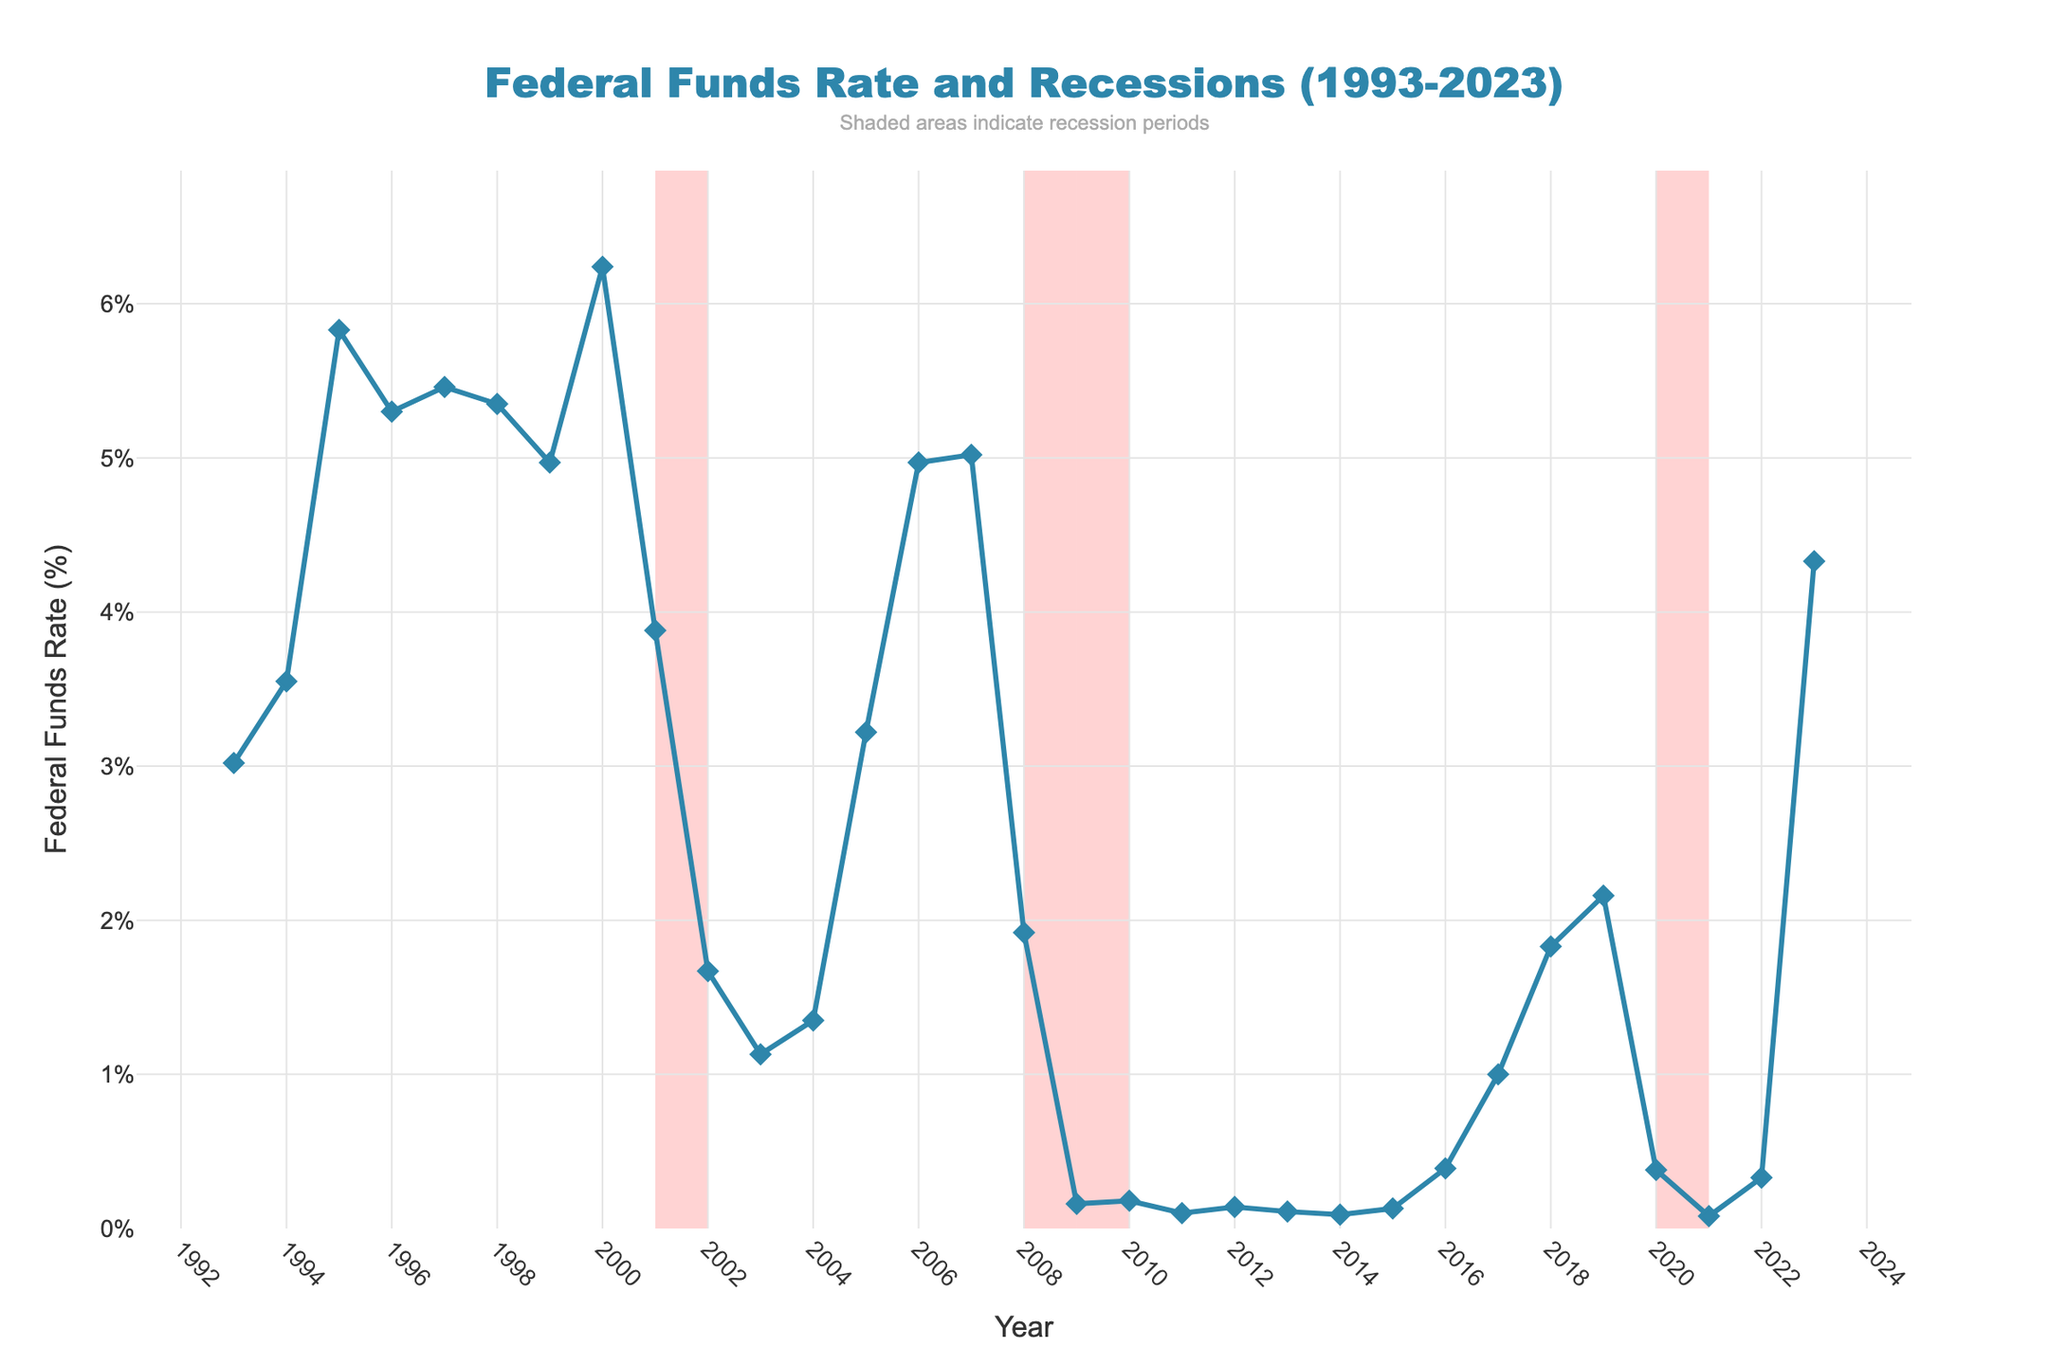What is the highest level reached by the Federal Funds Rate over the past 30 years? The highest rate can be identified by looking for the peak value on the Federal Funds Rate line on the chart. This peak occurs around the year 2000.
Answer: 6.24% During which years did recessions occur as highlighted in the chart? Recessions are indicated by shaded areas in the chart. The shaded areas correspond to the years 2001, 2008-2009, and 2020.
Answer: 2001, 2008-2009, 2020 Compare the Federal Funds Rate at the beginning and at the end of the 30-year period. Was it higher in 1993 or 2023? The Federal Funds Rate in January 1993 is 3.02%, and in January 2023, it is 4.33%. Therefore, the rate was higher in 2023.
Answer: 2023 By how much did the Federal Funds Rate change from 2000 to 2001? To find this, subtract the rate in 2001 from the rate in 2000. The Federal Funds Rate in 2000 was 6.24%, and in 2001 it was 3.88%. Therefore, the change is 6.24% - 3.88% = 2.36%.
Answer: 2.36% What is the average Federal Funds Rate during the 2008-2009 recession period? During the 2008-2009 recession, the rates are 1.92% for 2008 and 0.16% for 2009. The average is calculated as (1.92% + 0.16%) / 2.
Answer: 1.04% How does the Federal Funds Rate trend change during recession periods compared to non-recession periods? During recession periods, the Federal Funds Rate generally drops significantly, whereas during non-recession periods, the rate shows a stabilized or increasing trend. This is visually identified by the sharp declines during shaded areas.
Answer: Drops during recessions Which year experienced the largest single-year decline in Federal Funds Rate, and what was the decline? Identifying the year with the largest drop involves examining the steepest downward slope between two consecutive time points. The largest decline appears between 2000 and 2001, going from 6.24% to 3.88%, a decline of 2.36%.
Answer: 2000 to 2001, 2.36% Visualize the changes in the Federal Funds Rate during the 2000-2003 timeframe. How did these changes correspond to the US economy's state? During 2000-2003, the rate dropped from 6.24% (2000) to 1.35% (2004), signifying a sharp reduction usually corresponding to economic downturns, such as the dot-com bubble burst and the 2001 recession.
Answer: Sharp reduction What observations can be made about the Federal Funds Rate during the period after 2010 up until 2023? The rate remains relatively low from 2010 to around 2016, then gradually increases toward 2020, declines sharply during the 2020 recession, and rises again sharply afterward.
Answer: Low then rise 